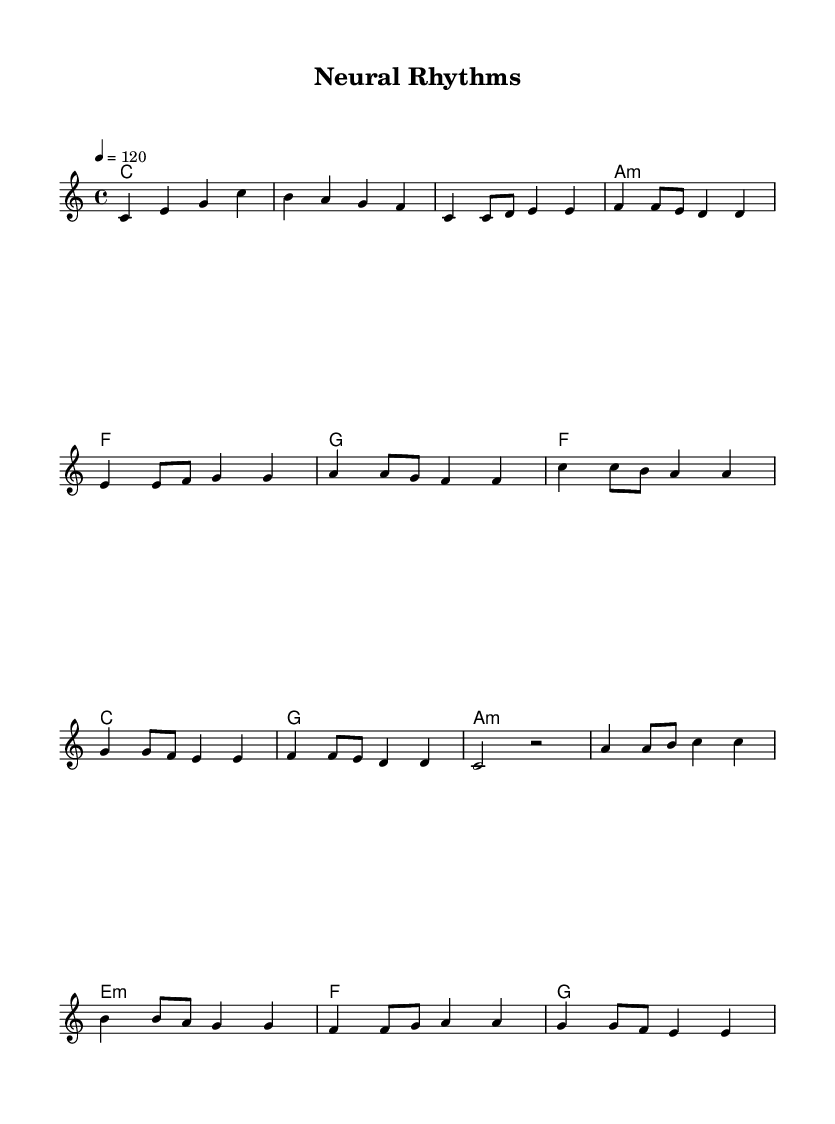What is the key signature of this music? The key signature is C major, which has no sharps or flats as indicated at the beginning of the sheet music.
Answer: C major What is the time signature of this music? The time signature is 4/4, represented in the beginning sections of the sheet music, indicating four beats per measure.
Answer: 4/4 What is the tempo marking of the piece? The tempo marking is 120, which tells musicians to play the piece at 120 beats per minute, as indicated at the start of the score.
Answer: 120 How many measures are in the verse section? The verse section contains four measures since each line within the verse block shows two measures, making it a total of four measures for the complete verse.
Answer: 4 What is the main tonality of the chorus? The main tonality in the chorus is C major, where the chords primarily revolve around C, A minor, G, and F, maintaining the C major tonality throughout.
Answer: C major What type of chords are used in the bridge section? The bridge section consists of minor chords and major chords, including A minor, E minor, F major, and G major, indicating a mix in harmonic texture.
Answer: Minor and Major What rhythmic pattern is prominent in the chorus? The rhythmic pattern in the chorus is characterized by alternating quarter notes and eighth notes before moving into half notes, creating a driving pop rhythm.
Answer: Alternating quarter and eighth notes 